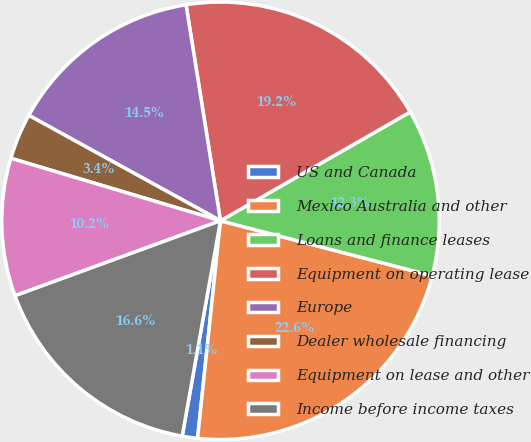<chart> <loc_0><loc_0><loc_500><loc_500><pie_chart><fcel>US and Canada<fcel>Mexico Australia and other<fcel>Loans and finance leases<fcel>Equipment on operating lease<fcel>Europe<fcel>Dealer wholesale financing<fcel>Equipment on lease and other<fcel>Income before income taxes<nl><fcel>1.13%<fcel>22.62%<fcel>12.33%<fcel>19.23%<fcel>14.48%<fcel>3.39%<fcel>10.18%<fcel>16.63%<nl></chart> 